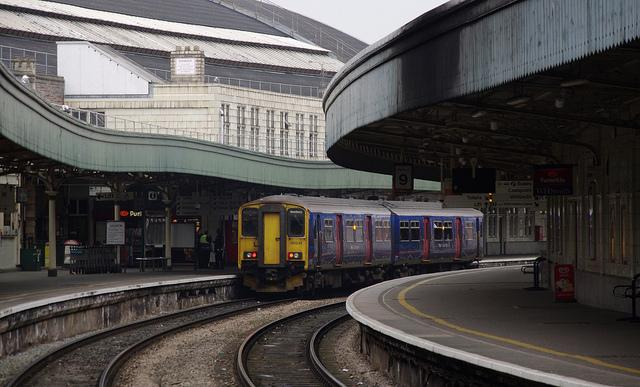Why is the yellow line painted on the ground? safety 